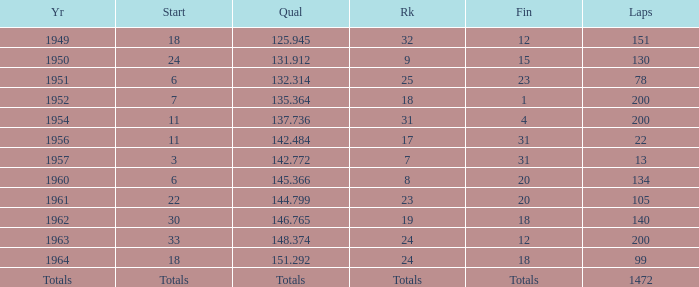Name the year for laps of 200 and rank of 24 1963.0. 